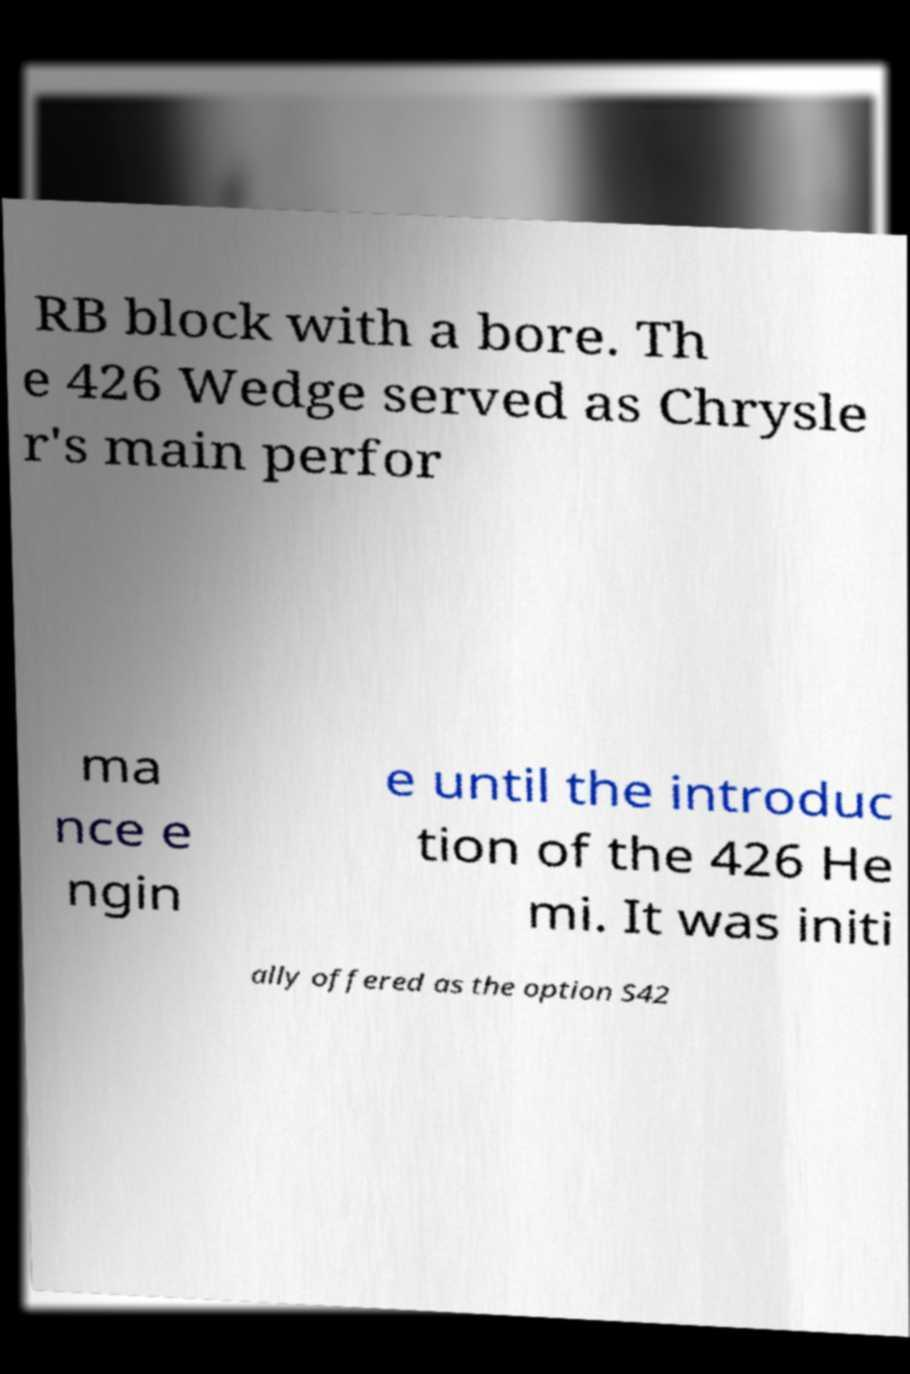There's text embedded in this image that I need extracted. Can you transcribe it verbatim? RB block with a bore. Th e 426 Wedge served as Chrysle r's main perfor ma nce e ngin e until the introduc tion of the 426 He mi. It was initi ally offered as the option S42 